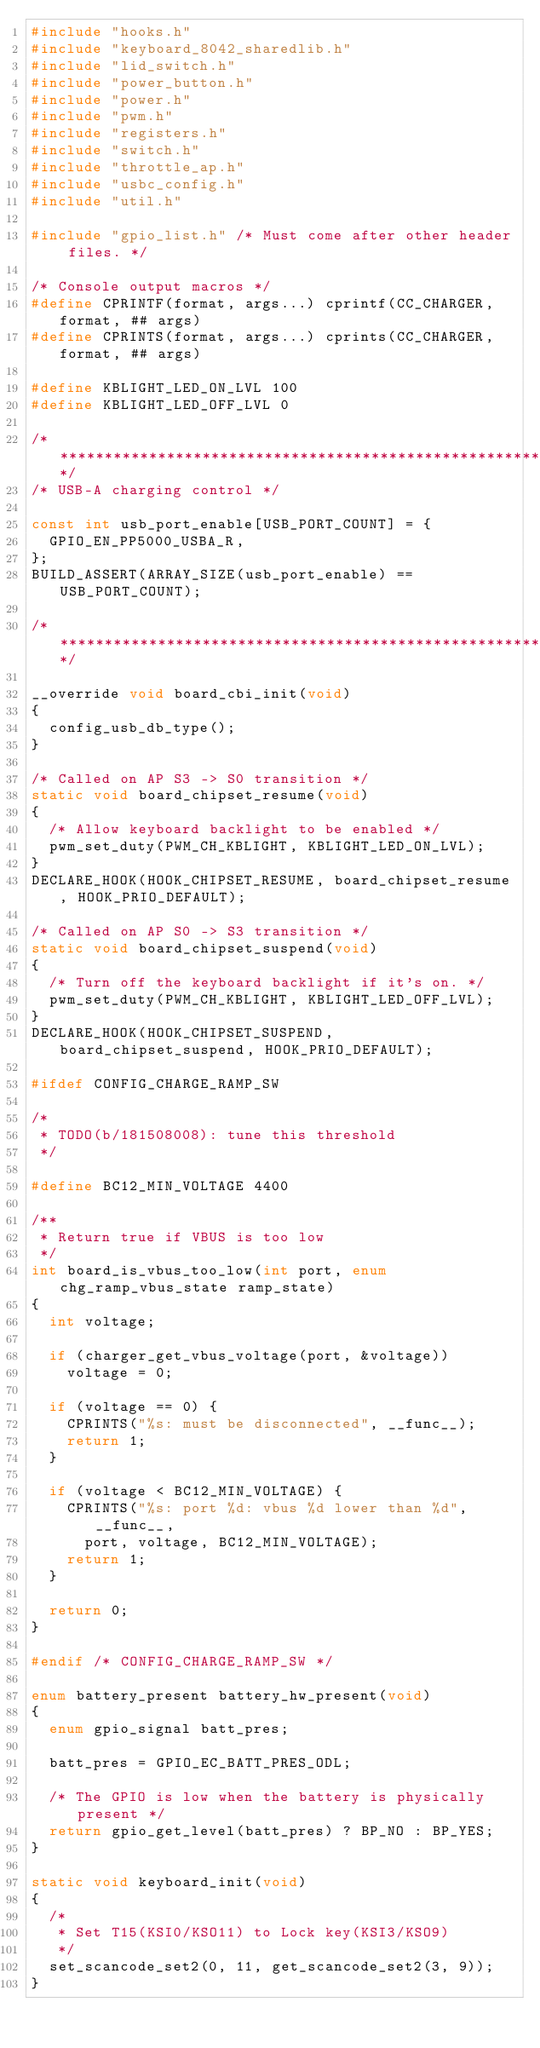<code> <loc_0><loc_0><loc_500><loc_500><_C_>#include "hooks.h"
#include "keyboard_8042_sharedlib.h"
#include "lid_switch.h"
#include "power_button.h"
#include "power.h"
#include "pwm.h"
#include "registers.h"
#include "switch.h"
#include "throttle_ap.h"
#include "usbc_config.h"
#include "util.h"

#include "gpio_list.h" /* Must come after other header files. */

/* Console output macros */
#define CPRINTF(format, args...) cprintf(CC_CHARGER, format, ## args)
#define CPRINTS(format, args...) cprints(CC_CHARGER, format, ## args)

#define KBLIGHT_LED_ON_LVL 100
#define KBLIGHT_LED_OFF_LVL 0

/******************************************************************************/
/* USB-A charging control */

const int usb_port_enable[USB_PORT_COUNT] = {
	GPIO_EN_PP5000_USBA_R,
};
BUILD_ASSERT(ARRAY_SIZE(usb_port_enable) == USB_PORT_COUNT);

/******************************************************************************/

__override void board_cbi_init(void)
{
	config_usb_db_type();
}

/* Called on AP S3 -> S0 transition */
static void board_chipset_resume(void)
{
	/* Allow keyboard backlight to be enabled */
	pwm_set_duty(PWM_CH_KBLIGHT, KBLIGHT_LED_ON_LVL);
}
DECLARE_HOOK(HOOK_CHIPSET_RESUME, board_chipset_resume, HOOK_PRIO_DEFAULT);

/* Called on AP S0 -> S3 transition */
static void board_chipset_suspend(void)
{
	/* Turn off the keyboard backlight if it's on. */
	pwm_set_duty(PWM_CH_KBLIGHT, KBLIGHT_LED_OFF_LVL);
}
DECLARE_HOOK(HOOK_CHIPSET_SUSPEND, board_chipset_suspend, HOOK_PRIO_DEFAULT);

#ifdef CONFIG_CHARGE_RAMP_SW

/*
 * TODO(b/181508008): tune this threshold
 */

#define BC12_MIN_VOLTAGE 4400

/**
 * Return true if VBUS is too low
 */
int board_is_vbus_too_low(int port, enum chg_ramp_vbus_state ramp_state)
{
	int voltage;

	if (charger_get_vbus_voltage(port, &voltage))
		voltage = 0;

	if (voltage == 0) {
		CPRINTS("%s: must be disconnected", __func__);
		return 1;
	}

	if (voltage < BC12_MIN_VOLTAGE) {
		CPRINTS("%s: port %d: vbus %d lower than %d", __func__,
			port, voltage, BC12_MIN_VOLTAGE);
		return 1;
	}

	return 0;
}

#endif /* CONFIG_CHARGE_RAMP_SW */

enum battery_present battery_hw_present(void)
{
	enum gpio_signal batt_pres;

	batt_pres = GPIO_EC_BATT_PRES_ODL;

	/* The GPIO is low when the battery is physically present */
	return gpio_get_level(batt_pres) ? BP_NO : BP_YES;
}

static void keyboard_init(void)
{
	/*
	 * Set T15(KSI0/KSO11) to Lock key(KSI3/KSO9)
	 */
	set_scancode_set2(0, 11, get_scancode_set2(3, 9));
}</code> 